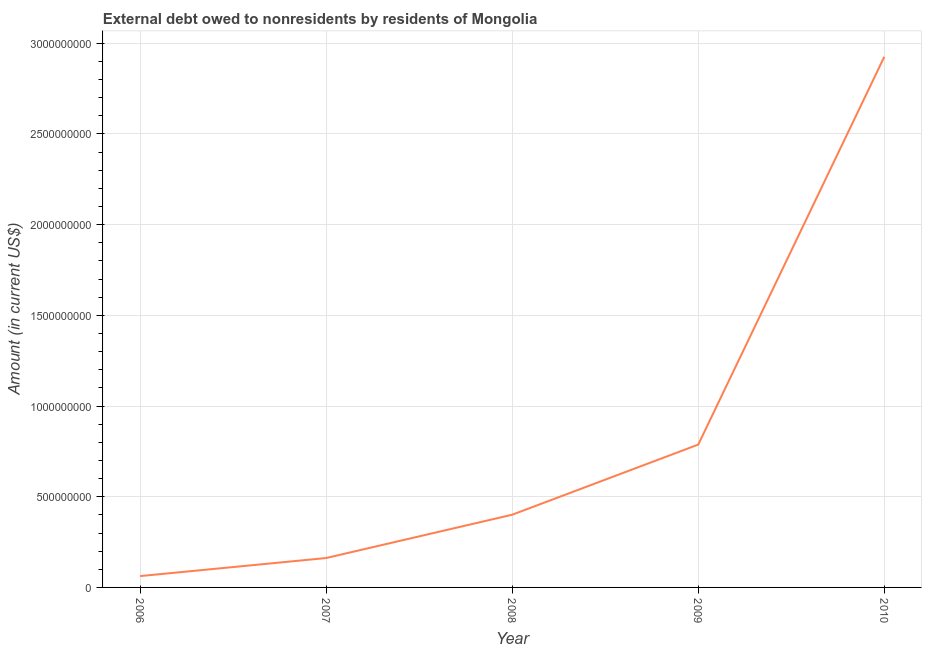What is the debt in 2006?
Offer a terse response. 6.25e+07. Across all years, what is the maximum debt?
Keep it short and to the point. 2.93e+09. Across all years, what is the minimum debt?
Give a very brief answer. 6.25e+07. In which year was the debt maximum?
Ensure brevity in your answer.  2010. In which year was the debt minimum?
Offer a terse response. 2006. What is the sum of the debt?
Your answer should be very brief. 4.34e+09. What is the difference between the debt in 2006 and 2008?
Provide a succinct answer. -3.38e+08. What is the average debt per year?
Keep it short and to the point. 8.68e+08. What is the median debt?
Your answer should be compact. 4.01e+08. Do a majority of the years between 2009 and 2007 (inclusive) have debt greater than 900000000 US$?
Make the answer very short. No. What is the ratio of the debt in 2009 to that in 2010?
Provide a succinct answer. 0.27. Is the debt in 2007 less than that in 2009?
Offer a very short reply. Yes. Is the difference between the debt in 2009 and 2010 greater than the difference between any two years?
Provide a short and direct response. No. What is the difference between the highest and the second highest debt?
Your answer should be very brief. 2.14e+09. Is the sum of the debt in 2009 and 2010 greater than the maximum debt across all years?
Offer a terse response. Yes. What is the difference between the highest and the lowest debt?
Make the answer very short. 2.86e+09. Does the debt monotonically increase over the years?
Your answer should be compact. Yes. How many years are there in the graph?
Provide a short and direct response. 5. What is the title of the graph?
Offer a very short reply. External debt owed to nonresidents by residents of Mongolia. What is the label or title of the Y-axis?
Make the answer very short. Amount (in current US$). What is the Amount (in current US$) of 2006?
Provide a succinct answer. 6.25e+07. What is the Amount (in current US$) in 2007?
Your response must be concise. 1.62e+08. What is the Amount (in current US$) of 2008?
Offer a very short reply. 4.01e+08. What is the Amount (in current US$) of 2009?
Offer a very short reply. 7.87e+08. What is the Amount (in current US$) of 2010?
Your answer should be very brief. 2.93e+09. What is the difference between the Amount (in current US$) in 2006 and 2007?
Your answer should be compact. -9.96e+07. What is the difference between the Amount (in current US$) in 2006 and 2008?
Give a very brief answer. -3.38e+08. What is the difference between the Amount (in current US$) in 2006 and 2009?
Offer a very short reply. -7.25e+08. What is the difference between the Amount (in current US$) in 2006 and 2010?
Provide a short and direct response. -2.86e+09. What is the difference between the Amount (in current US$) in 2007 and 2008?
Your answer should be compact. -2.39e+08. What is the difference between the Amount (in current US$) in 2007 and 2009?
Make the answer very short. -6.25e+08. What is the difference between the Amount (in current US$) in 2007 and 2010?
Offer a very short reply. -2.76e+09. What is the difference between the Amount (in current US$) in 2008 and 2009?
Provide a succinct answer. -3.87e+08. What is the difference between the Amount (in current US$) in 2008 and 2010?
Your answer should be compact. -2.52e+09. What is the difference between the Amount (in current US$) in 2009 and 2010?
Give a very brief answer. -2.14e+09. What is the ratio of the Amount (in current US$) in 2006 to that in 2007?
Make the answer very short. 0.39. What is the ratio of the Amount (in current US$) in 2006 to that in 2008?
Ensure brevity in your answer.  0.16. What is the ratio of the Amount (in current US$) in 2006 to that in 2009?
Ensure brevity in your answer.  0.08. What is the ratio of the Amount (in current US$) in 2006 to that in 2010?
Your answer should be very brief. 0.02. What is the ratio of the Amount (in current US$) in 2007 to that in 2008?
Give a very brief answer. 0.4. What is the ratio of the Amount (in current US$) in 2007 to that in 2009?
Make the answer very short. 0.21. What is the ratio of the Amount (in current US$) in 2007 to that in 2010?
Give a very brief answer. 0.06. What is the ratio of the Amount (in current US$) in 2008 to that in 2009?
Offer a very short reply. 0.51. What is the ratio of the Amount (in current US$) in 2008 to that in 2010?
Provide a short and direct response. 0.14. What is the ratio of the Amount (in current US$) in 2009 to that in 2010?
Give a very brief answer. 0.27. 